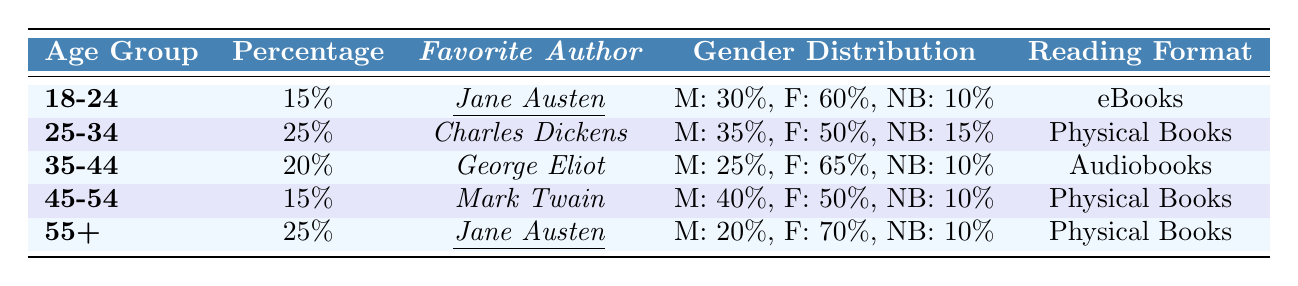What percentage of readers aged 25-34 prefer physical books? The table shows that for the age group 25-34, the percentage of readers is 25%, and their preferred reading format is physical books.
Answer: 25% Which age group has the highest percentage of readers enjoying classic literature? The age group 25-34 has a percentage of 25%, which is the highest compared to the other age groups listed.
Answer: 25-34 Is Jane Austen the favorite author for more than one age group? According to the table, Jane Austen is the favorite author for the age groups 18-24 and 55+, confirming that she is favored by more than one age group.
Answer: Yes What is the gender distribution of readers aged 35-44? For the age group 35-44, the gender distribution is male: 25%, female: 65%, and non-binary: 10%.
Answer: Male: 25%, Female: 65%, Non-binary: 10% How many percent of readers aged 45-54 favor physical books? The table indicates that 15% of readers in the age group 45-54 enjoy classic literature, and they prefer physical books as their reading format.
Answer: 15% If you consider only the percentages of readers for ages 18-24 and 55+, what is the average percentage? The percentages for ages 18-24 and 55+ are 15% and 25%, respectively. The sum is 15% + 25% = 40%. The average is 40% / 2 = 20%.
Answer: 20% Which age group has the highest female representation among classic literature readers? Looking at the gender distribution, the age group 55+ has 70% female representation, which is higher than other age groups.
Answer: 55+ What are the preferred reading formats of all age groups combined? From the table, the reading formats are eBooks for 18-24, Physical Books for 25-34 and 45-54, Audiobooks for 35-44, and Physical Books for 55+. This indicates a preference for both Physical Books and eBooks but not a unified format across all age groups.
Answer: eBooks, Physical Books, Audiobooks Is the preference for Jane Austen equally distributed in both age groups that favor her? In the age group 18-24, 60% are female and 30% male; in the age group 55+, 70% are female and 20% male. The female preference is higher in both groups, indicating that the preference is not equally distributed.
Answer: No What percentage of non-binary readers exists in the 25-34 age group? For the age group 25-34, the gender distribution shows that 15% of readers identify as non-binary.
Answer: 15% 